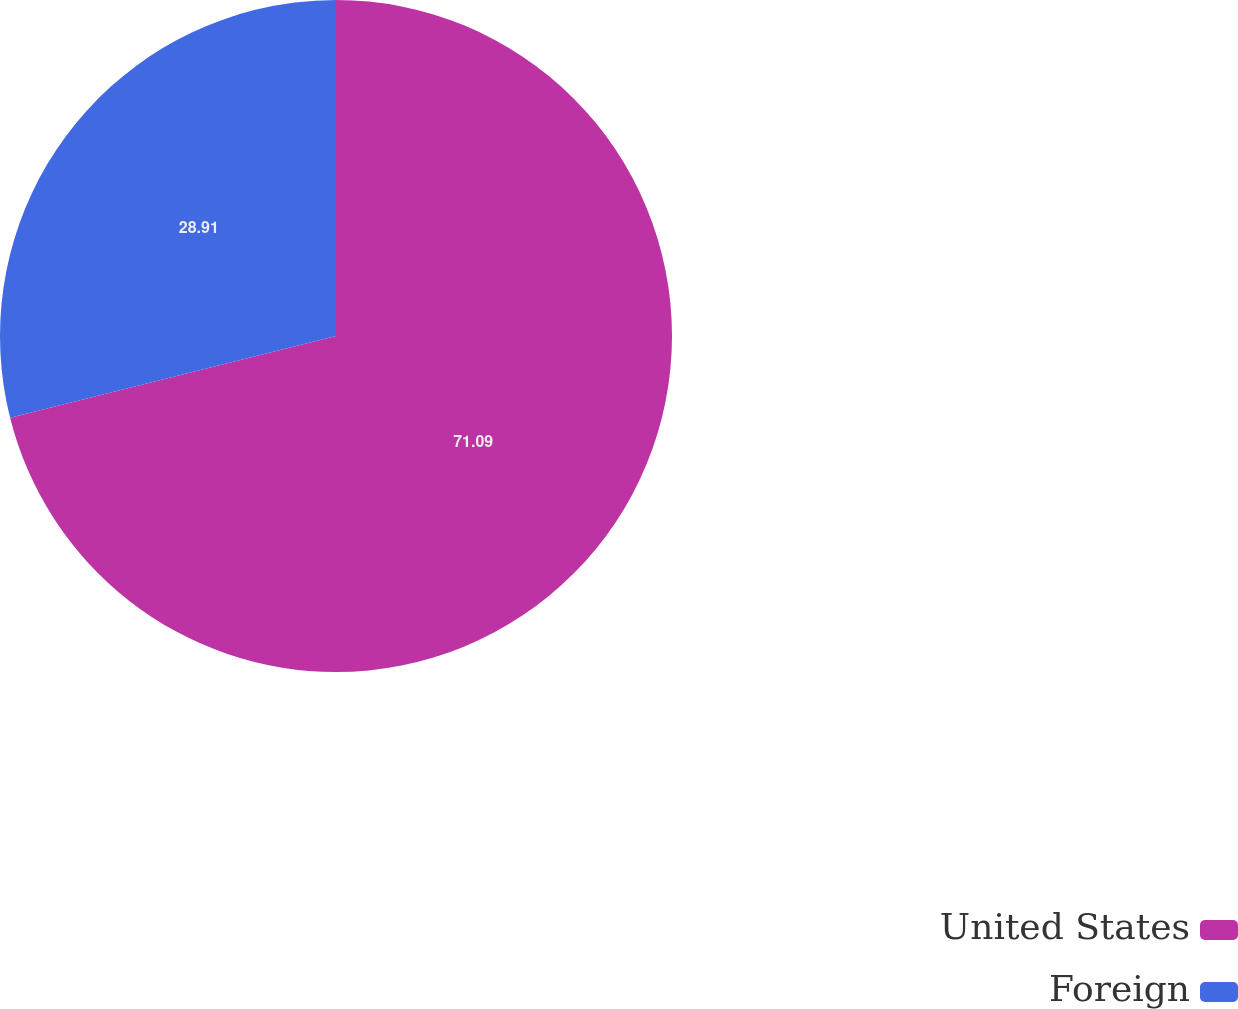Convert chart to OTSL. <chart><loc_0><loc_0><loc_500><loc_500><pie_chart><fcel>United States<fcel>Foreign<nl><fcel>71.09%<fcel>28.91%<nl></chart> 